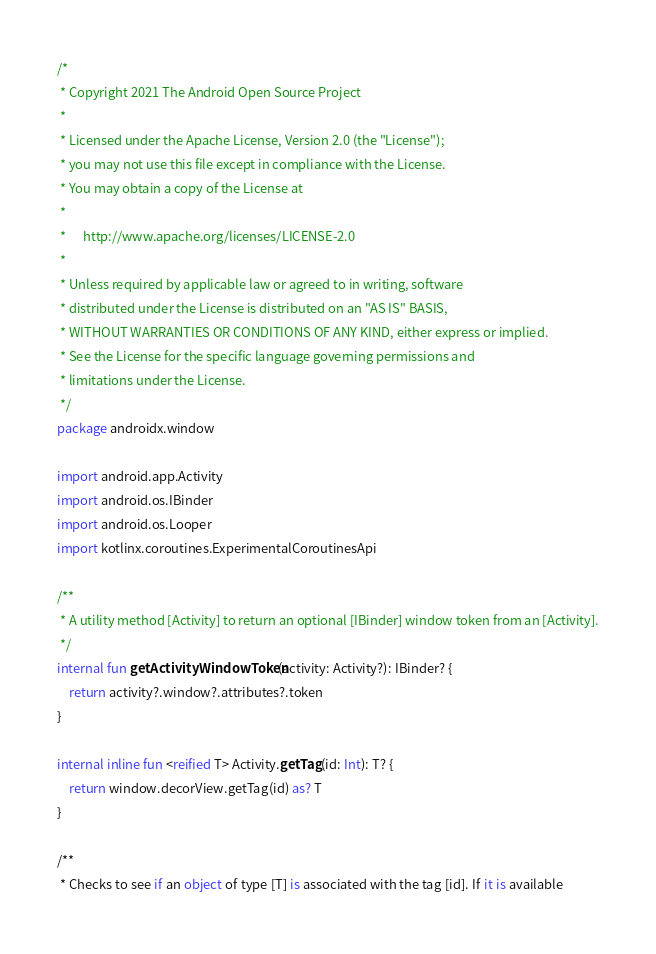<code> <loc_0><loc_0><loc_500><loc_500><_Kotlin_>/*
 * Copyright 2021 The Android Open Source Project
 *
 * Licensed under the Apache License, Version 2.0 (the "License");
 * you may not use this file except in compliance with the License.
 * You may obtain a copy of the License at
 *
 *      http://www.apache.org/licenses/LICENSE-2.0
 *
 * Unless required by applicable law or agreed to in writing, software
 * distributed under the License is distributed on an "AS IS" BASIS,
 * WITHOUT WARRANTIES OR CONDITIONS OF ANY KIND, either express or implied.
 * See the License for the specific language governing permissions and
 * limitations under the License.
 */
package androidx.window

import android.app.Activity
import android.os.IBinder
import android.os.Looper
import kotlinx.coroutines.ExperimentalCoroutinesApi

/**
 * A utility method [Activity] to return an optional [IBinder] window token from an [Activity].
 */
internal fun getActivityWindowToken(activity: Activity?): IBinder? {
    return activity?.window?.attributes?.token
}

internal inline fun <reified T> Activity.getTag(id: Int): T? {
    return window.decorView.getTag(id) as? T
}

/**
 * Checks to see if an object of type [T] is associated with the tag [id]. If it is available</code> 